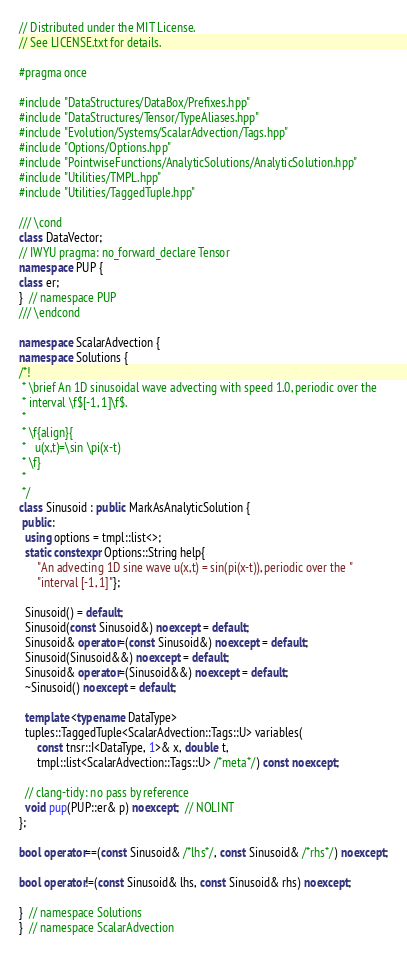Convert code to text. <code><loc_0><loc_0><loc_500><loc_500><_C++_>// Distributed under the MIT License.
// See LICENSE.txt for details.

#pragma once

#include "DataStructures/DataBox/Prefixes.hpp"
#include "DataStructures/Tensor/TypeAliases.hpp"
#include "Evolution/Systems/ScalarAdvection/Tags.hpp"
#include "Options/Options.hpp"
#include "PointwiseFunctions/AnalyticSolutions/AnalyticSolution.hpp"
#include "Utilities/TMPL.hpp"
#include "Utilities/TaggedTuple.hpp"

/// \cond
class DataVector;
// IWYU pragma: no_forward_declare Tensor
namespace PUP {
class er;
}  // namespace PUP
/// \endcond

namespace ScalarAdvection {
namespace Solutions {
/*!
 * \brief An 1D sinusoidal wave advecting with speed 1.0, periodic over the
 * interval \f$[-1, 1]\f$.
 *
 * \f{align}{
 *   u(x,t)=\sin \pi(x-t)
 * \f}
 *
 */
class Sinusoid : public MarkAsAnalyticSolution {
 public:
  using options = tmpl::list<>;
  static constexpr Options::String help{
      "An advecting 1D sine wave u(x,t) = sin(pi(x-t)), periodic over the "
      "interval [-1, 1]"};

  Sinusoid() = default;
  Sinusoid(const Sinusoid&) noexcept = default;
  Sinusoid& operator=(const Sinusoid&) noexcept = default;
  Sinusoid(Sinusoid&&) noexcept = default;
  Sinusoid& operator=(Sinusoid&&) noexcept = default;
  ~Sinusoid() noexcept = default;

  template <typename DataType>
  tuples::TaggedTuple<ScalarAdvection::Tags::U> variables(
      const tnsr::I<DataType, 1>& x, double t,
      tmpl::list<ScalarAdvection::Tags::U> /*meta*/) const noexcept;

  // clang-tidy: no pass by reference
  void pup(PUP::er& p) noexcept;  // NOLINT
};

bool operator==(const Sinusoid& /*lhs*/, const Sinusoid& /*rhs*/) noexcept;

bool operator!=(const Sinusoid& lhs, const Sinusoid& rhs) noexcept;

}  // namespace Solutions
}  // namespace ScalarAdvection
</code> 